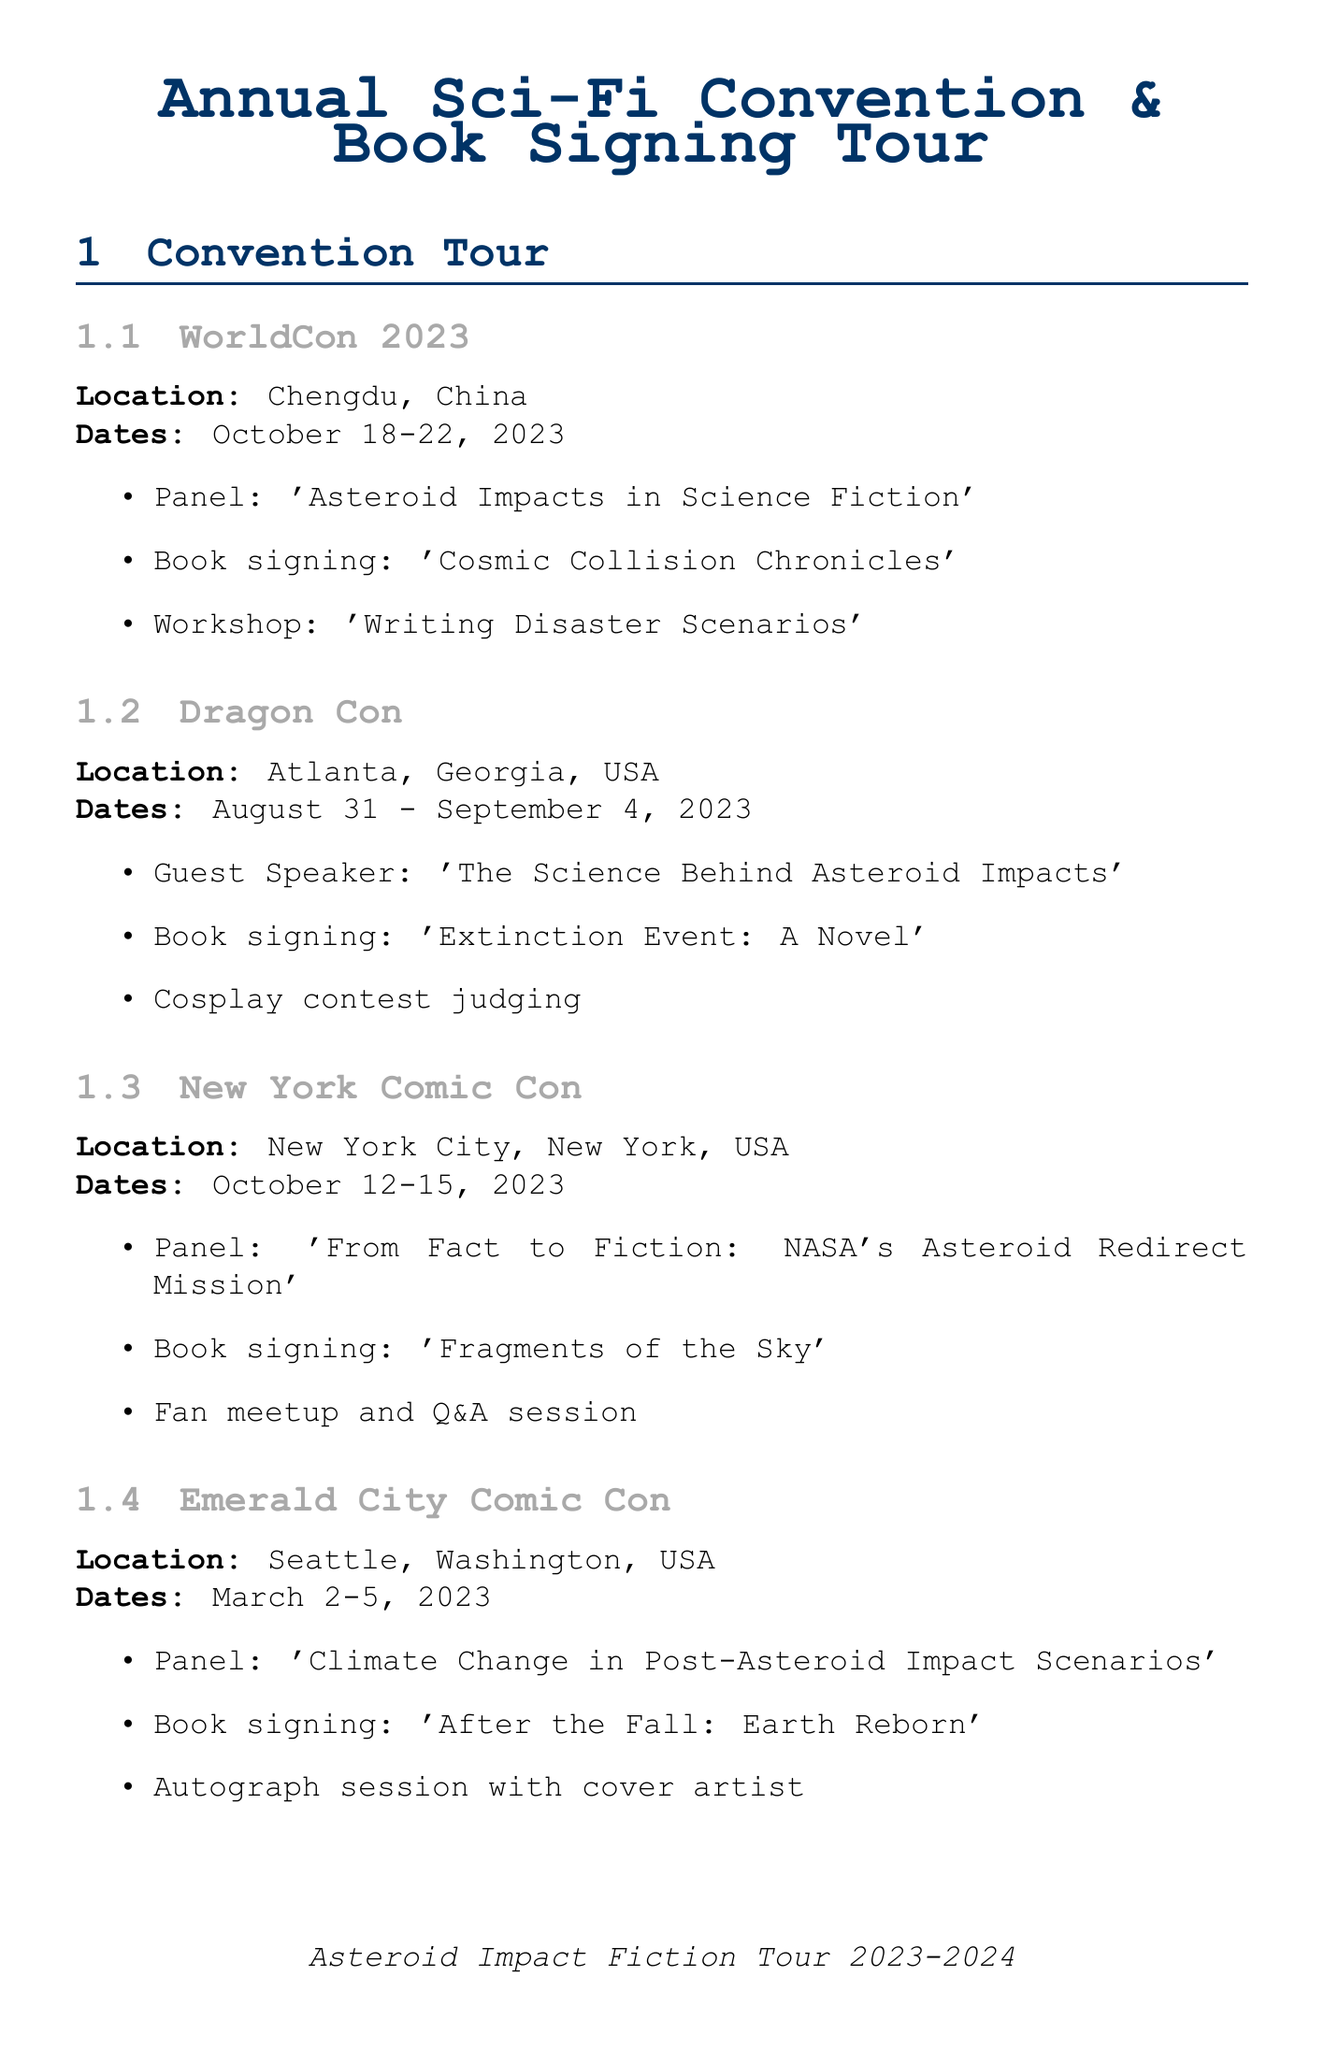What are the dates for WorldCon 2023? WorldCon 2023 takes place from October 18 to October 22, 2023.
Answer: October 18-22, 2023 Where is the panel on 'Asteroid Impacts in Science Fiction' held? The panel is part of the WorldCon 2023 event, which is located in Chengdu, China.
Answer: Chengdu, China What is the title of the book being signed at Forbidden Planet? The event at Forbidden Planet includes a signing for 'Impact: 2072'.
Answer: Impact: 2072 Which event takes place on September 15, 2023? This date features a Reddit AMA session about asteroid impact fiction.
Answer: Reddit AMA What is the name of the book launch at LonCon 4? The book launch at LonCon 4 is for 'The Chicxulub Legacy'.
Answer: The Chicxulub Legacy How many science center events are listed? The document lists three science center events.
Answer: 3 Which city hosts the signing for 'Fragments of the Sky'? The signing for 'Fragments of the Sky' is at The Strand, in New York City.
Answer: New York City What type of event is taking place at the Hayden Planetarium? The event at the Hayden Planetarium is a lecture.
Answer: Lecture What is the location for the Q&A session on November 30, 2023? The Q&A session takes place on Goodreads.com.
Answer: Goodreads.com 